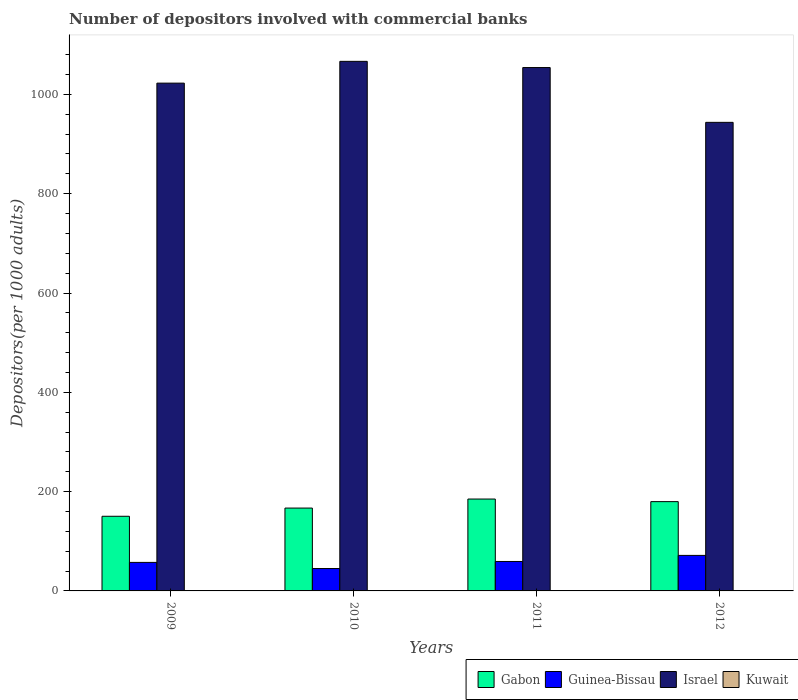How many groups of bars are there?
Offer a very short reply. 4. What is the label of the 1st group of bars from the left?
Make the answer very short. 2009. In how many cases, is the number of bars for a given year not equal to the number of legend labels?
Your answer should be very brief. 0. What is the number of depositors involved with commercial banks in Guinea-Bissau in 2009?
Provide a succinct answer. 57.45. Across all years, what is the maximum number of depositors involved with commercial banks in Guinea-Bissau?
Ensure brevity in your answer.  71.54. Across all years, what is the minimum number of depositors involved with commercial banks in Gabon?
Offer a terse response. 150.34. What is the total number of depositors involved with commercial banks in Kuwait in the graph?
Provide a succinct answer. 2.15. What is the difference between the number of depositors involved with commercial banks in Israel in 2010 and that in 2012?
Provide a short and direct response. 122.84. What is the difference between the number of depositors involved with commercial banks in Gabon in 2010 and the number of depositors involved with commercial banks in Israel in 2012?
Keep it short and to the point. -776.85. What is the average number of depositors involved with commercial banks in Kuwait per year?
Your answer should be very brief. 0.54. In the year 2009, what is the difference between the number of depositors involved with commercial banks in Guinea-Bissau and number of depositors involved with commercial banks in Israel?
Provide a succinct answer. -965.25. What is the ratio of the number of depositors involved with commercial banks in Gabon in 2010 to that in 2012?
Give a very brief answer. 0.93. Is the number of depositors involved with commercial banks in Gabon in 2010 less than that in 2012?
Keep it short and to the point. Yes. Is the difference between the number of depositors involved with commercial banks in Guinea-Bissau in 2009 and 2011 greater than the difference between the number of depositors involved with commercial banks in Israel in 2009 and 2011?
Your answer should be compact. Yes. What is the difference between the highest and the second highest number of depositors involved with commercial banks in Israel?
Keep it short and to the point. 12.5. What is the difference between the highest and the lowest number of depositors involved with commercial banks in Kuwait?
Ensure brevity in your answer.  0.07. Is the sum of the number of depositors involved with commercial banks in Israel in 2009 and 2012 greater than the maximum number of depositors involved with commercial banks in Gabon across all years?
Your answer should be very brief. Yes. What does the 1st bar from the left in 2009 represents?
Make the answer very short. Gabon. Is it the case that in every year, the sum of the number of depositors involved with commercial banks in Israel and number of depositors involved with commercial banks in Kuwait is greater than the number of depositors involved with commercial banks in Gabon?
Offer a very short reply. Yes. How many bars are there?
Provide a succinct answer. 16. Are all the bars in the graph horizontal?
Make the answer very short. No. How many years are there in the graph?
Your response must be concise. 4. Are the values on the major ticks of Y-axis written in scientific E-notation?
Offer a very short reply. No. Does the graph contain any zero values?
Give a very brief answer. No. What is the title of the graph?
Ensure brevity in your answer.  Number of depositors involved with commercial banks. What is the label or title of the Y-axis?
Offer a very short reply. Depositors(per 1000 adults). What is the Depositors(per 1000 adults) of Gabon in 2009?
Offer a terse response. 150.34. What is the Depositors(per 1000 adults) of Guinea-Bissau in 2009?
Your response must be concise. 57.45. What is the Depositors(per 1000 adults) of Israel in 2009?
Your response must be concise. 1022.7. What is the Depositors(per 1000 adults) in Kuwait in 2009?
Offer a terse response. 0.52. What is the Depositors(per 1000 adults) of Gabon in 2010?
Your answer should be compact. 166.87. What is the Depositors(per 1000 adults) of Guinea-Bissau in 2010?
Ensure brevity in your answer.  45.11. What is the Depositors(per 1000 adults) in Israel in 2010?
Offer a very short reply. 1066.56. What is the Depositors(per 1000 adults) of Kuwait in 2010?
Offer a very short reply. 0.51. What is the Depositors(per 1000 adults) of Gabon in 2011?
Ensure brevity in your answer.  185.06. What is the Depositors(per 1000 adults) in Guinea-Bissau in 2011?
Offer a terse response. 59.29. What is the Depositors(per 1000 adults) in Israel in 2011?
Keep it short and to the point. 1054.06. What is the Depositors(per 1000 adults) of Kuwait in 2011?
Make the answer very short. 0.53. What is the Depositors(per 1000 adults) of Gabon in 2012?
Your answer should be very brief. 179.84. What is the Depositors(per 1000 adults) in Guinea-Bissau in 2012?
Provide a succinct answer. 71.54. What is the Depositors(per 1000 adults) of Israel in 2012?
Offer a terse response. 943.72. What is the Depositors(per 1000 adults) of Kuwait in 2012?
Keep it short and to the point. 0.59. Across all years, what is the maximum Depositors(per 1000 adults) of Gabon?
Offer a very short reply. 185.06. Across all years, what is the maximum Depositors(per 1000 adults) of Guinea-Bissau?
Provide a succinct answer. 71.54. Across all years, what is the maximum Depositors(per 1000 adults) in Israel?
Ensure brevity in your answer.  1066.56. Across all years, what is the maximum Depositors(per 1000 adults) of Kuwait?
Provide a short and direct response. 0.59. Across all years, what is the minimum Depositors(per 1000 adults) in Gabon?
Your answer should be compact. 150.34. Across all years, what is the minimum Depositors(per 1000 adults) of Guinea-Bissau?
Offer a very short reply. 45.11. Across all years, what is the minimum Depositors(per 1000 adults) of Israel?
Give a very brief answer. 943.72. Across all years, what is the minimum Depositors(per 1000 adults) of Kuwait?
Your answer should be very brief. 0.51. What is the total Depositors(per 1000 adults) of Gabon in the graph?
Offer a terse response. 682.11. What is the total Depositors(per 1000 adults) of Guinea-Bissau in the graph?
Keep it short and to the point. 233.39. What is the total Depositors(per 1000 adults) of Israel in the graph?
Your answer should be compact. 4087.04. What is the total Depositors(per 1000 adults) of Kuwait in the graph?
Provide a short and direct response. 2.15. What is the difference between the Depositors(per 1000 adults) of Gabon in 2009 and that in 2010?
Your answer should be compact. -16.54. What is the difference between the Depositors(per 1000 adults) of Guinea-Bissau in 2009 and that in 2010?
Provide a succinct answer. 12.34. What is the difference between the Depositors(per 1000 adults) of Israel in 2009 and that in 2010?
Your answer should be compact. -43.86. What is the difference between the Depositors(per 1000 adults) of Kuwait in 2009 and that in 2010?
Your answer should be very brief. 0.01. What is the difference between the Depositors(per 1000 adults) of Gabon in 2009 and that in 2011?
Provide a succinct answer. -34.72. What is the difference between the Depositors(per 1000 adults) in Guinea-Bissau in 2009 and that in 2011?
Your response must be concise. -1.84. What is the difference between the Depositors(per 1000 adults) in Israel in 2009 and that in 2011?
Your answer should be very brief. -31.36. What is the difference between the Depositors(per 1000 adults) in Kuwait in 2009 and that in 2011?
Offer a terse response. -0. What is the difference between the Depositors(per 1000 adults) in Gabon in 2009 and that in 2012?
Offer a very short reply. -29.5. What is the difference between the Depositors(per 1000 adults) in Guinea-Bissau in 2009 and that in 2012?
Offer a very short reply. -14.09. What is the difference between the Depositors(per 1000 adults) in Israel in 2009 and that in 2012?
Give a very brief answer. 78.98. What is the difference between the Depositors(per 1000 adults) in Kuwait in 2009 and that in 2012?
Your response must be concise. -0.06. What is the difference between the Depositors(per 1000 adults) of Gabon in 2010 and that in 2011?
Your response must be concise. -18.18. What is the difference between the Depositors(per 1000 adults) in Guinea-Bissau in 2010 and that in 2011?
Give a very brief answer. -14.18. What is the difference between the Depositors(per 1000 adults) of Israel in 2010 and that in 2011?
Make the answer very short. 12.5. What is the difference between the Depositors(per 1000 adults) in Kuwait in 2010 and that in 2011?
Provide a short and direct response. -0.01. What is the difference between the Depositors(per 1000 adults) of Gabon in 2010 and that in 2012?
Your answer should be very brief. -12.97. What is the difference between the Depositors(per 1000 adults) of Guinea-Bissau in 2010 and that in 2012?
Provide a succinct answer. -26.43. What is the difference between the Depositors(per 1000 adults) in Israel in 2010 and that in 2012?
Your answer should be very brief. 122.84. What is the difference between the Depositors(per 1000 adults) of Kuwait in 2010 and that in 2012?
Your response must be concise. -0.07. What is the difference between the Depositors(per 1000 adults) in Gabon in 2011 and that in 2012?
Make the answer very short. 5.22. What is the difference between the Depositors(per 1000 adults) in Guinea-Bissau in 2011 and that in 2012?
Provide a short and direct response. -12.25. What is the difference between the Depositors(per 1000 adults) in Israel in 2011 and that in 2012?
Your answer should be compact. 110.33. What is the difference between the Depositors(per 1000 adults) of Kuwait in 2011 and that in 2012?
Your answer should be very brief. -0.06. What is the difference between the Depositors(per 1000 adults) of Gabon in 2009 and the Depositors(per 1000 adults) of Guinea-Bissau in 2010?
Keep it short and to the point. 105.23. What is the difference between the Depositors(per 1000 adults) in Gabon in 2009 and the Depositors(per 1000 adults) in Israel in 2010?
Your response must be concise. -916.22. What is the difference between the Depositors(per 1000 adults) of Gabon in 2009 and the Depositors(per 1000 adults) of Kuwait in 2010?
Provide a short and direct response. 149.82. What is the difference between the Depositors(per 1000 adults) of Guinea-Bissau in 2009 and the Depositors(per 1000 adults) of Israel in 2010?
Ensure brevity in your answer.  -1009.11. What is the difference between the Depositors(per 1000 adults) of Guinea-Bissau in 2009 and the Depositors(per 1000 adults) of Kuwait in 2010?
Provide a succinct answer. 56.93. What is the difference between the Depositors(per 1000 adults) in Israel in 2009 and the Depositors(per 1000 adults) in Kuwait in 2010?
Your response must be concise. 1022.19. What is the difference between the Depositors(per 1000 adults) in Gabon in 2009 and the Depositors(per 1000 adults) in Guinea-Bissau in 2011?
Offer a terse response. 91.05. What is the difference between the Depositors(per 1000 adults) of Gabon in 2009 and the Depositors(per 1000 adults) of Israel in 2011?
Your response must be concise. -903.72. What is the difference between the Depositors(per 1000 adults) in Gabon in 2009 and the Depositors(per 1000 adults) in Kuwait in 2011?
Provide a succinct answer. 149.81. What is the difference between the Depositors(per 1000 adults) in Guinea-Bissau in 2009 and the Depositors(per 1000 adults) in Israel in 2011?
Offer a very short reply. -996.61. What is the difference between the Depositors(per 1000 adults) in Guinea-Bissau in 2009 and the Depositors(per 1000 adults) in Kuwait in 2011?
Give a very brief answer. 56.92. What is the difference between the Depositors(per 1000 adults) in Israel in 2009 and the Depositors(per 1000 adults) in Kuwait in 2011?
Ensure brevity in your answer.  1022.17. What is the difference between the Depositors(per 1000 adults) in Gabon in 2009 and the Depositors(per 1000 adults) in Guinea-Bissau in 2012?
Your answer should be very brief. 78.8. What is the difference between the Depositors(per 1000 adults) of Gabon in 2009 and the Depositors(per 1000 adults) of Israel in 2012?
Your answer should be very brief. -793.39. What is the difference between the Depositors(per 1000 adults) in Gabon in 2009 and the Depositors(per 1000 adults) in Kuwait in 2012?
Your answer should be compact. 149.75. What is the difference between the Depositors(per 1000 adults) in Guinea-Bissau in 2009 and the Depositors(per 1000 adults) in Israel in 2012?
Give a very brief answer. -886.28. What is the difference between the Depositors(per 1000 adults) in Guinea-Bissau in 2009 and the Depositors(per 1000 adults) in Kuwait in 2012?
Keep it short and to the point. 56.86. What is the difference between the Depositors(per 1000 adults) in Israel in 2009 and the Depositors(per 1000 adults) in Kuwait in 2012?
Keep it short and to the point. 1022.12. What is the difference between the Depositors(per 1000 adults) of Gabon in 2010 and the Depositors(per 1000 adults) of Guinea-Bissau in 2011?
Provide a succinct answer. 107.58. What is the difference between the Depositors(per 1000 adults) of Gabon in 2010 and the Depositors(per 1000 adults) of Israel in 2011?
Make the answer very short. -887.18. What is the difference between the Depositors(per 1000 adults) in Gabon in 2010 and the Depositors(per 1000 adults) in Kuwait in 2011?
Your response must be concise. 166.35. What is the difference between the Depositors(per 1000 adults) of Guinea-Bissau in 2010 and the Depositors(per 1000 adults) of Israel in 2011?
Your response must be concise. -1008.95. What is the difference between the Depositors(per 1000 adults) in Guinea-Bissau in 2010 and the Depositors(per 1000 adults) in Kuwait in 2011?
Offer a terse response. 44.58. What is the difference between the Depositors(per 1000 adults) in Israel in 2010 and the Depositors(per 1000 adults) in Kuwait in 2011?
Keep it short and to the point. 1066.03. What is the difference between the Depositors(per 1000 adults) of Gabon in 2010 and the Depositors(per 1000 adults) of Guinea-Bissau in 2012?
Provide a succinct answer. 95.33. What is the difference between the Depositors(per 1000 adults) of Gabon in 2010 and the Depositors(per 1000 adults) of Israel in 2012?
Ensure brevity in your answer.  -776.85. What is the difference between the Depositors(per 1000 adults) of Gabon in 2010 and the Depositors(per 1000 adults) of Kuwait in 2012?
Ensure brevity in your answer.  166.29. What is the difference between the Depositors(per 1000 adults) in Guinea-Bissau in 2010 and the Depositors(per 1000 adults) in Israel in 2012?
Provide a succinct answer. -898.61. What is the difference between the Depositors(per 1000 adults) in Guinea-Bissau in 2010 and the Depositors(per 1000 adults) in Kuwait in 2012?
Provide a short and direct response. 44.53. What is the difference between the Depositors(per 1000 adults) of Israel in 2010 and the Depositors(per 1000 adults) of Kuwait in 2012?
Give a very brief answer. 1065.98. What is the difference between the Depositors(per 1000 adults) in Gabon in 2011 and the Depositors(per 1000 adults) in Guinea-Bissau in 2012?
Your answer should be compact. 113.52. What is the difference between the Depositors(per 1000 adults) in Gabon in 2011 and the Depositors(per 1000 adults) in Israel in 2012?
Your answer should be compact. -758.67. What is the difference between the Depositors(per 1000 adults) in Gabon in 2011 and the Depositors(per 1000 adults) in Kuwait in 2012?
Ensure brevity in your answer.  184.47. What is the difference between the Depositors(per 1000 adults) in Guinea-Bissau in 2011 and the Depositors(per 1000 adults) in Israel in 2012?
Your answer should be very brief. -884.43. What is the difference between the Depositors(per 1000 adults) of Guinea-Bissau in 2011 and the Depositors(per 1000 adults) of Kuwait in 2012?
Make the answer very short. 58.71. What is the difference between the Depositors(per 1000 adults) in Israel in 2011 and the Depositors(per 1000 adults) in Kuwait in 2012?
Ensure brevity in your answer.  1053.47. What is the average Depositors(per 1000 adults) in Gabon per year?
Your response must be concise. 170.53. What is the average Depositors(per 1000 adults) of Guinea-Bissau per year?
Give a very brief answer. 58.35. What is the average Depositors(per 1000 adults) in Israel per year?
Offer a very short reply. 1021.76. What is the average Depositors(per 1000 adults) in Kuwait per year?
Your answer should be compact. 0.54. In the year 2009, what is the difference between the Depositors(per 1000 adults) of Gabon and Depositors(per 1000 adults) of Guinea-Bissau?
Offer a terse response. 92.89. In the year 2009, what is the difference between the Depositors(per 1000 adults) in Gabon and Depositors(per 1000 adults) in Israel?
Your answer should be compact. -872.36. In the year 2009, what is the difference between the Depositors(per 1000 adults) in Gabon and Depositors(per 1000 adults) in Kuwait?
Your answer should be compact. 149.81. In the year 2009, what is the difference between the Depositors(per 1000 adults) of Guinea-Bissau and Depositors(per 1000 adults) of Israel?
Offer a terse response. -965.25. In the year 2009, what is the difference between the Depositors(per 1000 adults) of Guinea-Bissau and Depositors(per 1000 adults) of Kuwait?
Your response must be concise. 56.92. In the year 2009, what is the difference between the Depositors(per 1000 adults) in Israel and Depositors(per 1000 adults) in Kuwait?
Provide a short and direct response. 1022.18. In the year 2010, what is the difference between the Depositors(per 1000 adults) of Gabon and Depositors(per 1000 adults) of Guinea-Bissau?
Provide a succinct answer. 121.76. In the year 2010, what is the difference between the Depositors(per 1000 adults) in Gabon and Depositors(per 1000 adults) in Israel?
Your response must be concise. -899.69. In the year 2010, what is the difference between the Depositors(per 1000 adults) in Gabon and Depositors(per 1000 adults) in Kuwait?
Offer a very short reply. 166.36. In the year 2010, what is the difference between the Depositors(per 1000 adults) in Guinea-Bissau and Depositors(per 1000 adults) in Israel?
Offer a very short reply. -1021.45. In the year 2010, what is the difference between the Depositors(per 1000 adults) of Guinea-Bissau and Depositors(per 1000 adults) of Kuwait?
Your response must be concise. 44.6. In the year 2010, what is the difference between the Depositors(per 1000 adults) of Israel and Depositors(per 1000 adults) of Kuwait?
Provide a succinct answer. 1066.05. In the year 2011, what is the difference between the Depositors(per 1000 adults) in Gabon and Depositors(per 1000 adults) in Guinea-Bissau?
Keep it short and to the point. 125.77. In the year 2011, what is the difference between the Depositors(per 1000 adults) in Gabon and Depositors(per 1000 adults) in Israel?
Provide a succinct answer. -869. In the year 2011, what is the difference between the Depositors(per 1000 adults) of Gabon and Depositors(per 1000 adults) of Kuwait?
Your answer should be very brief. 184.53. In the year 2011, what is the difference between the Depositors(per 1000 adults) of Guinea-Bissau and Depositors(per 1000 adults) of Israel?
Offer a terse response. -994.77. In the year 2011, what is the difference between the Depositors(per 1000 adults) in Guinea-Bissau and Depositors(per 1000 adults) in Kuwait?
Keep it short and to the point. 58.76. In the year 2011, what is the difference between the Depositors(per 1000 adults) of Israel and Depositors(per 1000 adults) of Kuwait?
Offer a terse response. 1053.53. In the year 2012, what is the difference between the Depositors(per 1000 adults) in Gabon and Depositors(per 1000 adults) in Guinea-Bissau?
Provide a succinct answer. 108.3. In the year 2012, what is the difference between the Depositors(per 1000 adults) of Gabon and Depositors(per 1000 adults) of Israel?
Keep it short and to the point. -763.88. In the year 2012, what is the difference between the Depositors(per 1000 adults) of Gabon and Depositors(per 1000 adults) of Kuwait?
Offer a terse response. 179.26. In the year 2012, what is the difference between the Depositors(per 1000 adults) in Guinea-Bissau and Depositors(per 1000 adults) in Israel?
Your response must be concise. -872.19. In the year 2012, what is the difference between the Depositors(per 1000 adults) of Guinea-Bissau and Depositors(per 1000 adults) of Kuwait?
Your answer should be very brief. 70.95. In the year 2012, what is the difference between the Depositors(per 1000 adults) in Israel and Depositors(per 1000 adults) in Kuwait?
Provide a succinct answer. 943.14. What is the ratio of the Depositors(per 1000 adults) in Gabon in 2009 to that in 2010?
Offer a very short reply. 0.9. What is the ratio of the Depositors(per 1000 adults) of Guinea-Bissau in 2009 to that in 2010?
Provide a succinct answer. 1.27. What is the ratio of the Depositors(per 1000 adults) in Israel in 2009 to that in 2010?
Give a very brief answer. 0.96. What is the ratio of the Depositors(per 1000 adults) in Kuwait in 2009 to that in 2010?
Offer a very short reply. 1.02. What is the ratio of the Depositors(per 1000 adults) of Gabon in 2009 to that in 2011?
Give a very brief answer. 0.81. What is the ratio of the Depositors(per 1000 adults) in Guinea-Bissau in 2009 to that in 2011?
Your answer should be compact. 0.97. What is the ratio of the Depositors(per 1000 adults) in Israel in 2009 to that in 2011?
Offer a terse response. 0.97. What is the ratio of the Depositors(per 1000 adults) in Kuwait in 2009 to that in 2011?
Offer a terse response. 0.99. What is the ratio of the Depositors(per 1000 adults) in Gabon in 2009 to that in 2012?
Keep it short and to the point. 0.84. What is the ratio of the Depositors(per 1000 adults) in Guinea-Bissau in 2009 to that in 2012?
Give a very brief answer. 0.8. What is the ratio of the Depositors(per 1000 adults) in Israel in 2009 to that in 2012?
Offer a very short reply. 1.08. What is the ratio of the Depositors(per 1000 adults) of Kuwait in 2009 to that in 2012?
Give a very brief answer. 0.9. What is the ratio of the Depositors(per 1000 adults) of Gabon in 2010 to that in 2011?
Keep it short and to the point. 0.9. What is the ratio of the Depositors(per 1000 adults) in Guinea-Bissau in 2010 to that in 2011?
Provide a short and direct response. 0.76. What is the ratio of the Depositors(per 1000 adults) in Israel in 2010 to that in 2011?
Make the answer very short. 1.01. What is the ratio of the Depositors(per 1000 adults) of Kuwait in 2010 to that in 2011?
Provide a short and direct response. 0.97. What is the ratio of the Depositors(per 1000 adults) of Gabon in 2010 to that in 2012?
Give a very brief answer. 0.93. What is the ratio of the Depositors(per 1000 adults) in Guinea-Bissau in 2010 to that in 2012?
Provide a short and direct response. 0.63. What is the ratio of the Depositors(per 1000 adults) in Israel in 2010 to that in 2012?
Offer a very short reply. 1.13. What is the ratio of the Depositors(per 1000 adults) of Kuwait in 2010 to that in 2012?
Provide a short and direct response. 0.88. What is the ratio of the Depositors(per 1000 adults) in Gabon in 2011 to that in 2012?
Provide a short and direct response. 1.03. What is the ratio of the Depositors(per 1000 adults) of Guinea-Bissau in 2011 to that in 2012?
Provide a short and direct response. 0.83. What is the ratio of the Depositors(per 1000 adults) in Israel in 2011 to that in 2012?
Ensure brevity in your answer.  1.12. What is the ratio of the Depositors(per 1000 adults) of Kuwait in 2011 to that in 2012?
Offer a terse response. 0.9. What is the difference between the highest and the second highest Depositors(per 1000 adults) in Gabon?
Make the answer very short. 5.22. What is the difference between the highest and the second highest Depositors(per 1000 adults) of Guinea-Bissau?
Offer a terse response. 12.25. What is the difference between the highest and the second highest Depositors(per 1000 adults) of Israel?
Your answer should be very brief. 12.5. What is the difference between the highest and the second highest Depositors(per 1000 adults) of Kuwait?
Your answer should be compact. 0.06. What is the difference between the highest and the lowest Depositors(per 1000 adults) of Gabon?
Your answer should be compact. 34.72. What is the difference between the highest and the lowest Depositors(per 1000 adults) in Guinea-Bissau?
Ensure brevity in your answer.  26.43. What is the difference between the highest and the lowest Depositors(per 1000 adults) of Israel?
Provide a succinct answer. 122.84. What is the difference between the highest and the lowest Depositors(per 1000 adults) in Kuwait?
Provide a short and direct response. 0.07. 